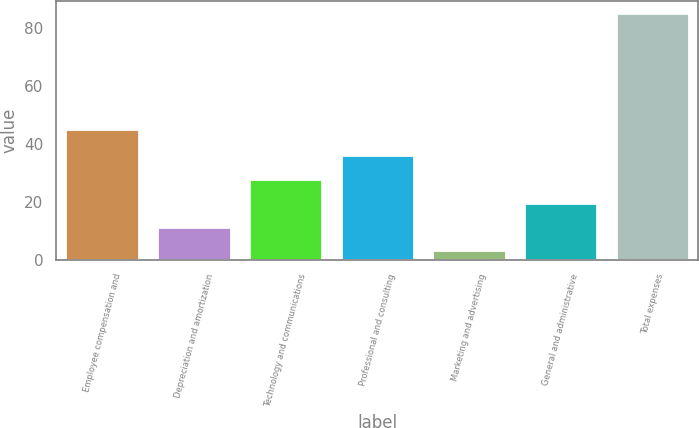<chart> <loc_0><loc_0><loc_500><loc_500><bar_chart><fcel>Employee compensation and<fcel>Depreciation and amortization<fcel>Technology and communications<fcel>Professional and consulting<fcel>Marketing and advertising<fcel>General and administrative<fcel>Total expenses<nl><fcel>45.1<fcel>11.5<fcel>27.9<fcel>36.1<fcel>3.3<fcel>19.7<fcel>85.3<nl></chart> 